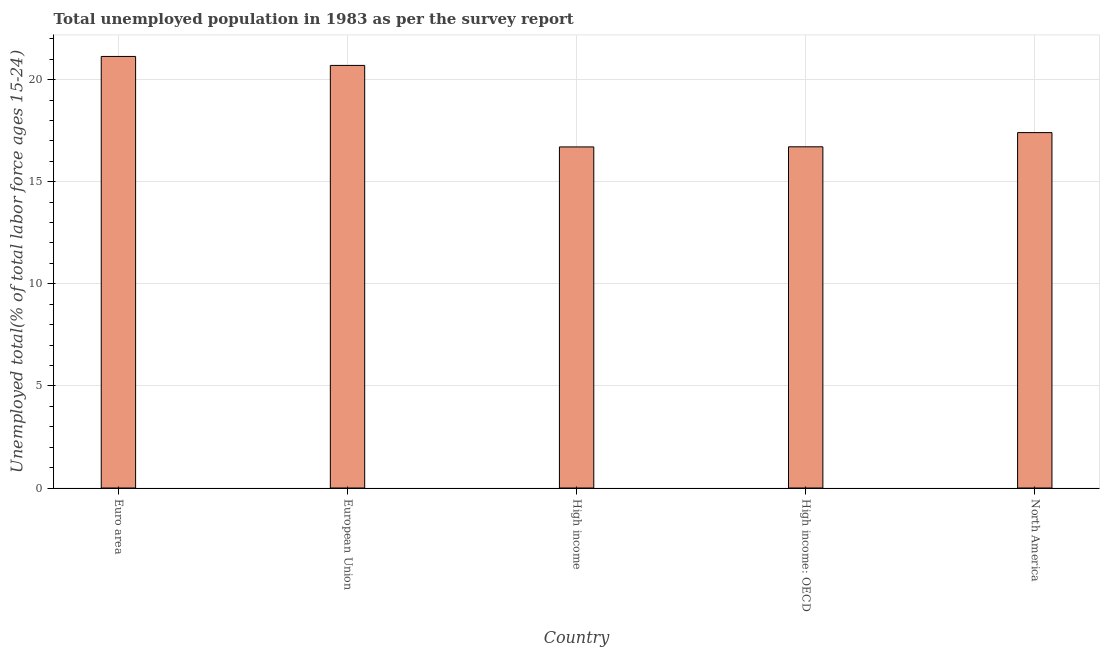Does the graph contain grids?
Your answer should be very brief. Yes. What is the title of the graph?
Your response must be concise. Total unemployed population in 1983 as per the survey report. What is the label or title of the Y-axis?
Ensure brevity in your answer.  Unemployed total(% of total labor force ages 15-24). What is the unemployed youth in High income: OECD?
Offer a terse response. 16.71. Across all countries, what is the maximum unemployed youth?
Ensure brevity in your answer.  21.13. Across all countries, what is the minimum unemployed youth?
Your answer should be very brief. 16.7. What is the sum of the unemployed youth?
Your answer should be compact. 92.65. What is the difference between the unemployed youth in Euro area and High income: OECD?
Your answer should be compact. 4.42. What is the average unemployed youth per country?
Ensure brevity in your answer.  18.53. What is the median unemployed youth?
Make the answer very short. 17.4. In how many countries, is the unemployed youth greater than 8 %?
Offer a terse response. 5. What is the ratio of the unemployed youth in High income: OECD to that in North America?
Offer a terse response. 0.96. Is the difference between the unemployed youth in European Union and High income: OECD greater than the difference between any two countries?
Your answer should be compact. No. What is the difference between the highest and the second highest unemployed youth?
Keep it short and to the point. 0.44. What is the difference between the highest and the lowest unemployed youth?
Offer a terse response. 4.43. How many bars are there?
Your answer should be compact. 5. Are all the bars in the graph horizontal?
Your answer should be compact. No. What is the difference between two consecutive major ticks on the Y-axis?
Give a very brief answer. 5. Are the values on the major ticks of Y-axis written in scientific E-notation?
Ensure brevity in your answer.  No. What is the Unemployed total(% of total labor force ages 15-24) of Euro area?
Offer a terse response. 21.13. What is the Unemployed total(% of total labor force ages 15-24) in European Union?
Make the answer very short. 20.69. What is the Unemployed total(% of total labor force ages 15-24) of High income?
Offer a terse response. 16.7. What is the Unemployed total(% of total labor force ages 15-24) of High income: OECD?
Offer a terse response. 16.71. What is the Unemployed total(% of total labor force ages 15-24) of North America?
Your answer should be very brief. 17.4. What is the difference between the Unemployed total(% of total labor force ages 15-24) in Euro area and European Union?
Your answer should be very brief. 0.44. What is the difference between the Unemployed total(% of total labor force ages 15-24) in Euro area and High income?
Keep it short and to the point. 4.43. What is the difference between the Unemployed total(% of total labor force ages 15-24) in Euro area and High income: OECD?
Provide a succinct answer. 4.42. What is the difference between the Unemployed total(% of total labor force ages 15-24) in Euro area and North America?
Keep it short and to the point. 3.73. What is the difference between the Unemployed total(% of total labor force ages 15-24) in European Union and High income?
Provide a short and direct response. 3.99. What is the difference between the Unemployed total(% of total labor force ages 15-24) in European Union and High income: OECD?
Your answer should be very brief. 3.99. What is the difference between the Unemployed total(% of total labor force ages 15-24) in European Union and North America?
Your response must be concise. 3.29. What is the difference between the Unemployed total(% of total labor force ages 15-24) in High income and High income: OECD?
Give a very brief answer. -0.01. What is the difference between the Unemployed total(% of total labor force ages 15-24) in High income and North America?
Offer a terse response. -0.7. What is the difference between the Unemployed total(% of total labor force ages 15-24) in High income: OECD and North America?
Offer a terse response. -0.7. What is the ratio of the Unemployed total(% of total labor force ages 15-24) in Euro area to that in European Union?
Give a very brief answer. 1.02. What is the ratio of the Unemployed total(% of total labor force ages 15-24) in Euro area to that in High income?
Ensure brevity in your answer.  1.26. What is the ratio of the Unemployed total(% of total labor force ages 15-24) in Euro area to that in High income: OECD?
Ensure brevity in your answer.  1.26. What is the ratio of the Unemployed total(% of total labor force ages 15-24) in Euro area to that in North America?
Give a very brief answer. 1.21. What is the ratio of the Unemployed total(% of total labor force ages 15-24) in European Union to that in High income?
Your answer should be very brief. 1.24. What is the ratio of the Unemployed total(% of total labor force ages 15-24) in European Union to that in High income: OECD?
Give a very brief answer. 1.24. What is the ratio of the Unemployed total(% of total labor force ages 15-24) in European Union to that in North America?
Your answer should be very brief. 1.19. What is the ratio of the Unemployed total(% of total labor force ages 15-24) in High income to that in North America?
Ensure brevity in your answer.  0.96. What is the ratio of the Unemployed total(% of total labor force ages 15-24) in High income: OECD to that in North America?
Your answer should be very brief. 0.96. 